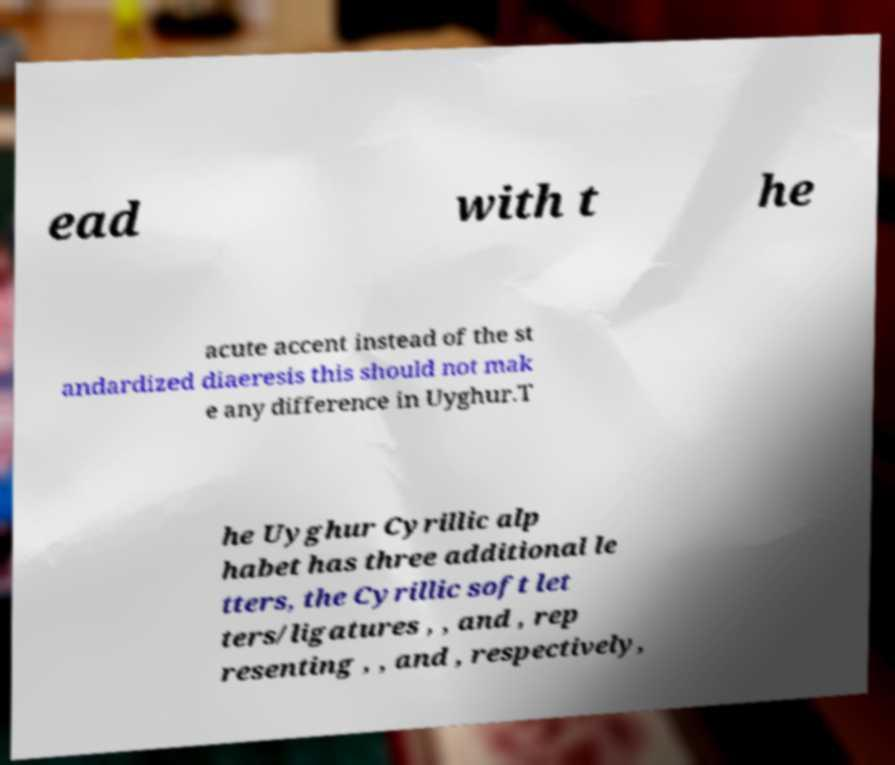There's text embedded in this image that I need extracted. Can you transcribe it verbatim? ead with t he acute accent instead of the st andardized diaeresis this should not mak e any difference in Uyghur.T he Uyghur Cyrillic alp habet has three additional le tters, the Cyrillic soft let ters/ligatures , , and , rep resenting , , and , respectively, 